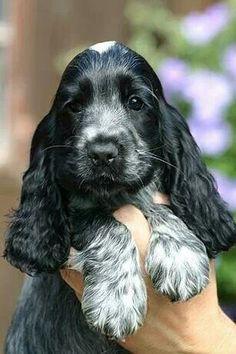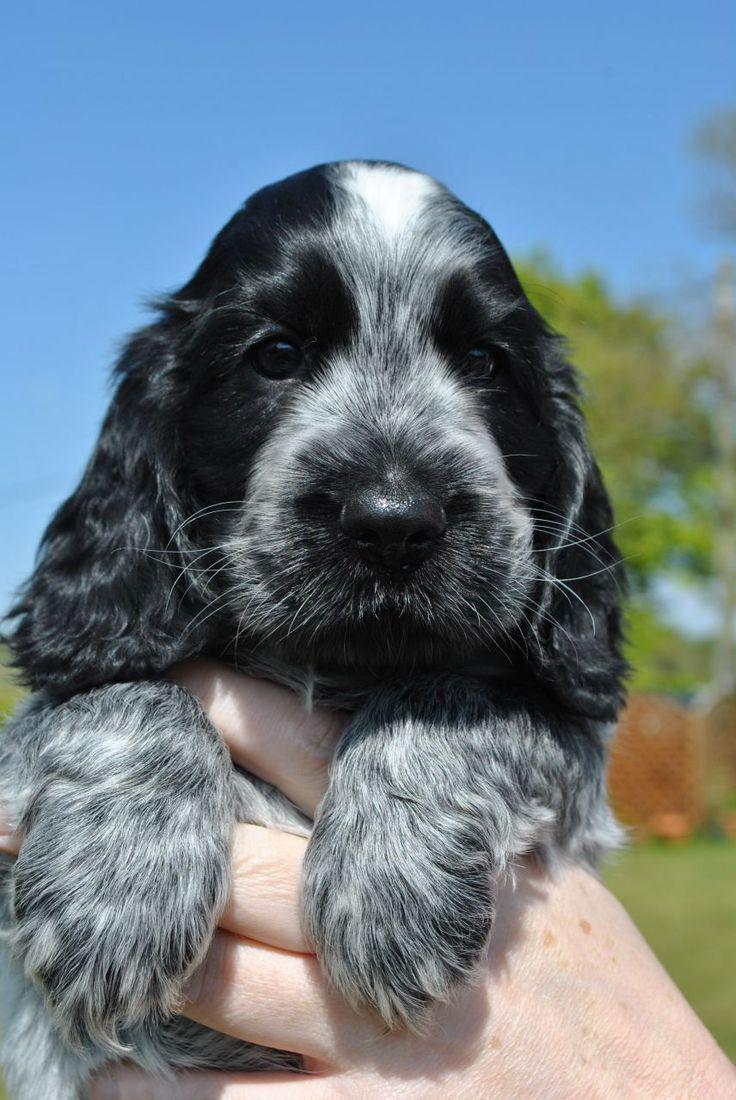The first image is the image on the left, the second image is the image on the right. Assess this claim about the two images: "An image shows one dog interacting with a stick-shaped item that is at least partly brown.". Correct or not? Answer yes or no. No. The first image is the image on the left, the second image is the image on the right. Evaluate the accuracy of this statement regarding the images: "The pair of images includes two dogs held by human hands.". Is it true? Answer yes or no. Yes. The first image is the image on the left, the second image is the image on the right. Considering the images on both sides, is "The dog in the image on the left is lying on the grass." valid? Answer yes or no. No. 